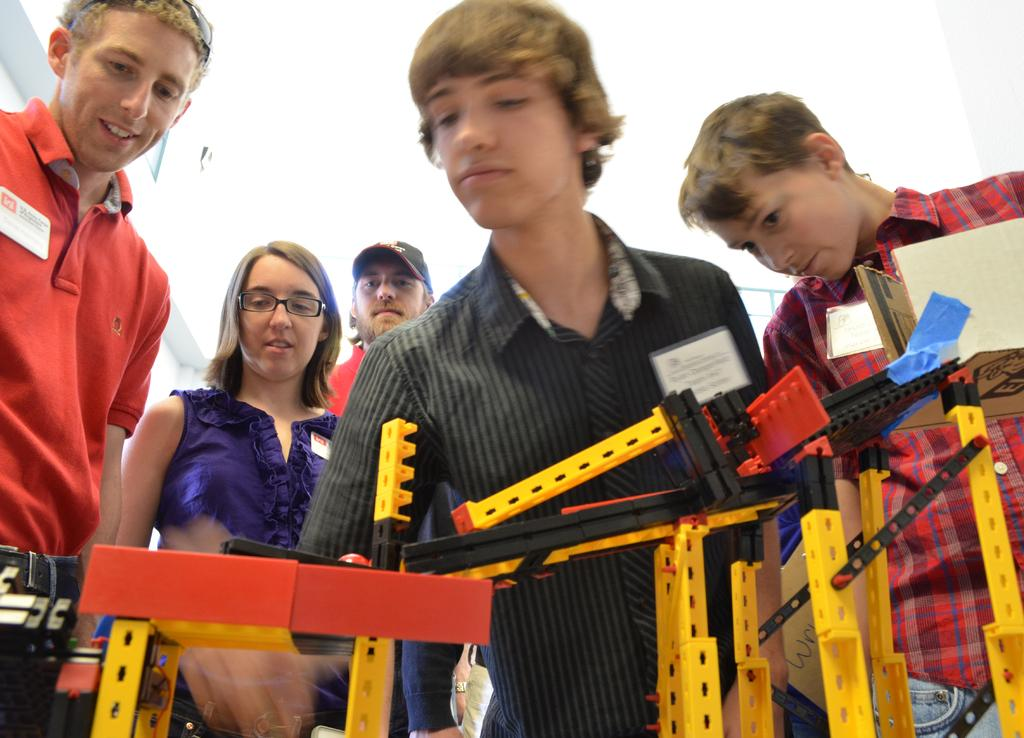Who or what can be seen in the image? There are people in the image. What can be observed on the people's clothes? The people have badges on their clothes. What is located at the bottom of the image? There are objects at the bottom of the image. What type of jail can be seen in the image? There is no jail present in the image. What kind of vessel is being used by the people in the image? There is no vessel present in the image. 